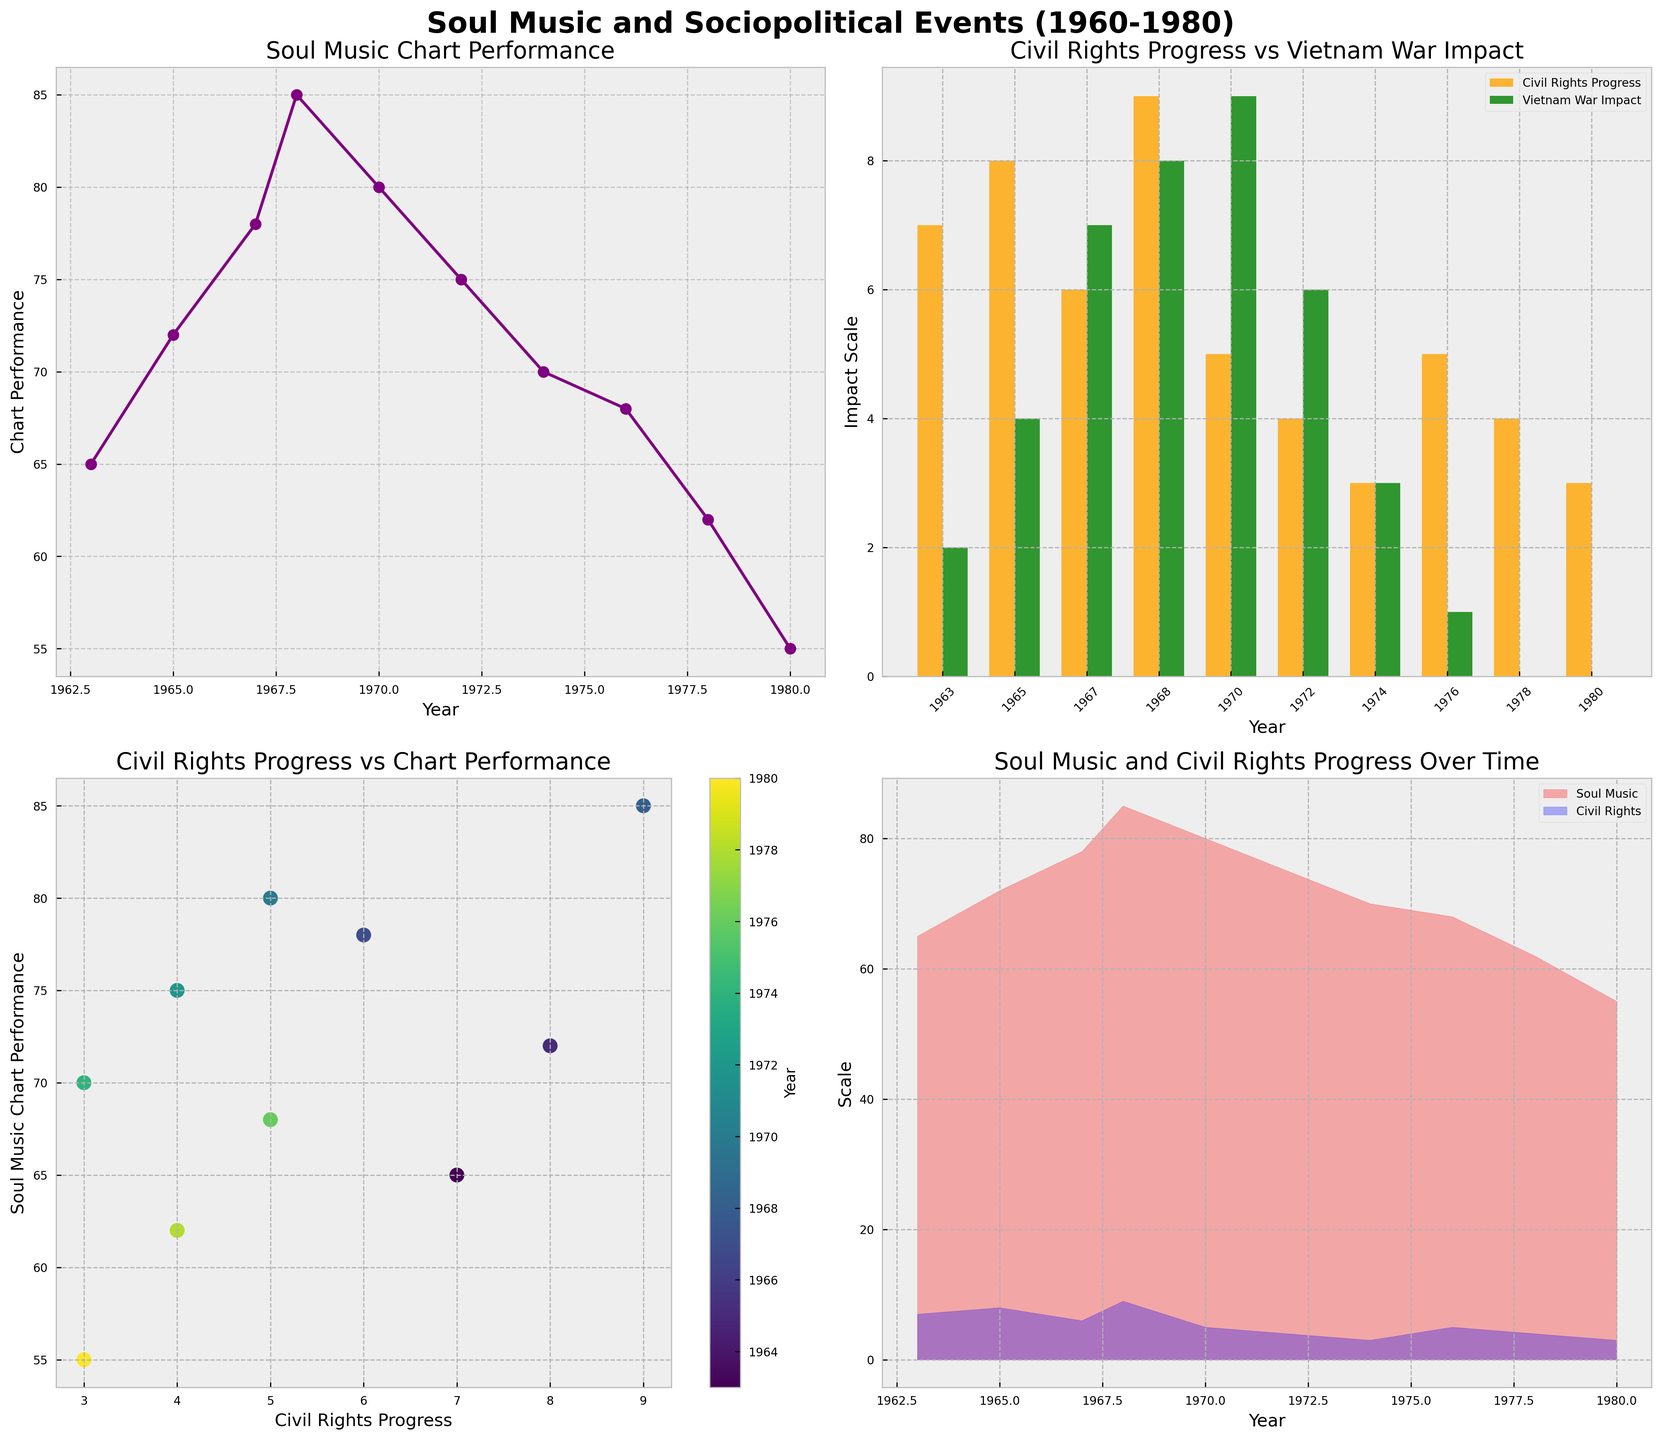What is the overall trend in soul music chart performance from 1963 to 1980? The line plot from the top-left subplot shows an overall decline in soul music chart performance from 1963 (65) to 1980 (55). There are fluctuations with peaks around 1968 and 1970 but the general trend is downward.
Answer: Decline Which year had the highest soul music chart performance? The line plot indicates that the highest soul music chart performance was in 1968, with a performance score of 85.
Answer: 1968 Compare the impacts of Civil Rights Progress and Vietnam War Impact in 1970 according to the bar plot. Which was more significant? The bar plot in the top-right subplot shows that in 1970, the impact of the Vietnam War (9) was more significant than the Civil Rights Progress (5).
Answer: Vietnam War Impact In the scatter plot, which year corresponds to the highest Civil Rights Progress score? The scatter plot shows the highest Civil Rights Progress score is 9, and the corresponding year for that score is 1968, represented by a dot towards the top-right of the plot.
Answer: 1968 How does soul music chart performance correlate with Civil Rights Progress based on the scatter plot? In the scatter plot, there is a positive correlation between Civil Rights Progress and Soul Music Chart Performance. Higher Civil Rights Progress scores tend to correspond to higher chart performance levels.
Answer: Positive correlation What event is associated with the year when the soul music chart performance started to decline after 1968? The line plot shows a decline in soul music chart performance after 1968, and the next event listed in 1970 on the x-axis is the Kent State Shootings.
Answer: Kent State Shootings Compare the soul music chart performance in 1965 and 1974 according to the line plot. Which year had better performance? In the line plot, 1965 had a soul music chart performance of 72, while 1974 had a performance of 70. Thus, 1965 had slightly better performance.
Answer: 1965 How did the Civil Rights Progress change from 1967 to 1968? The bar plot shows an increase in Civil Rights Progress from 6 in 1967 to 9 in 1968.
Answer: Increased What can we infer about the sociopolitical environment in 1980 relative to earlier years based on the stacked area plot? The stacked area plot shows both lower scores for Civil Rights Progress and Soul Music Chart Performance in 1980 compared to earlier years such as 1968, indicating potentially less favorable sociopolitical conditions for soul music.
Answer: Less favorable What is the difference in impact scale of Civil Rights Progress between 1963 and 1976 based on the bar plot? The bar plot shows Civil Rights Progress at 7 in 1963 and 5 in 1976. The difference is 7 - 5 = 2.
Answer: 2 